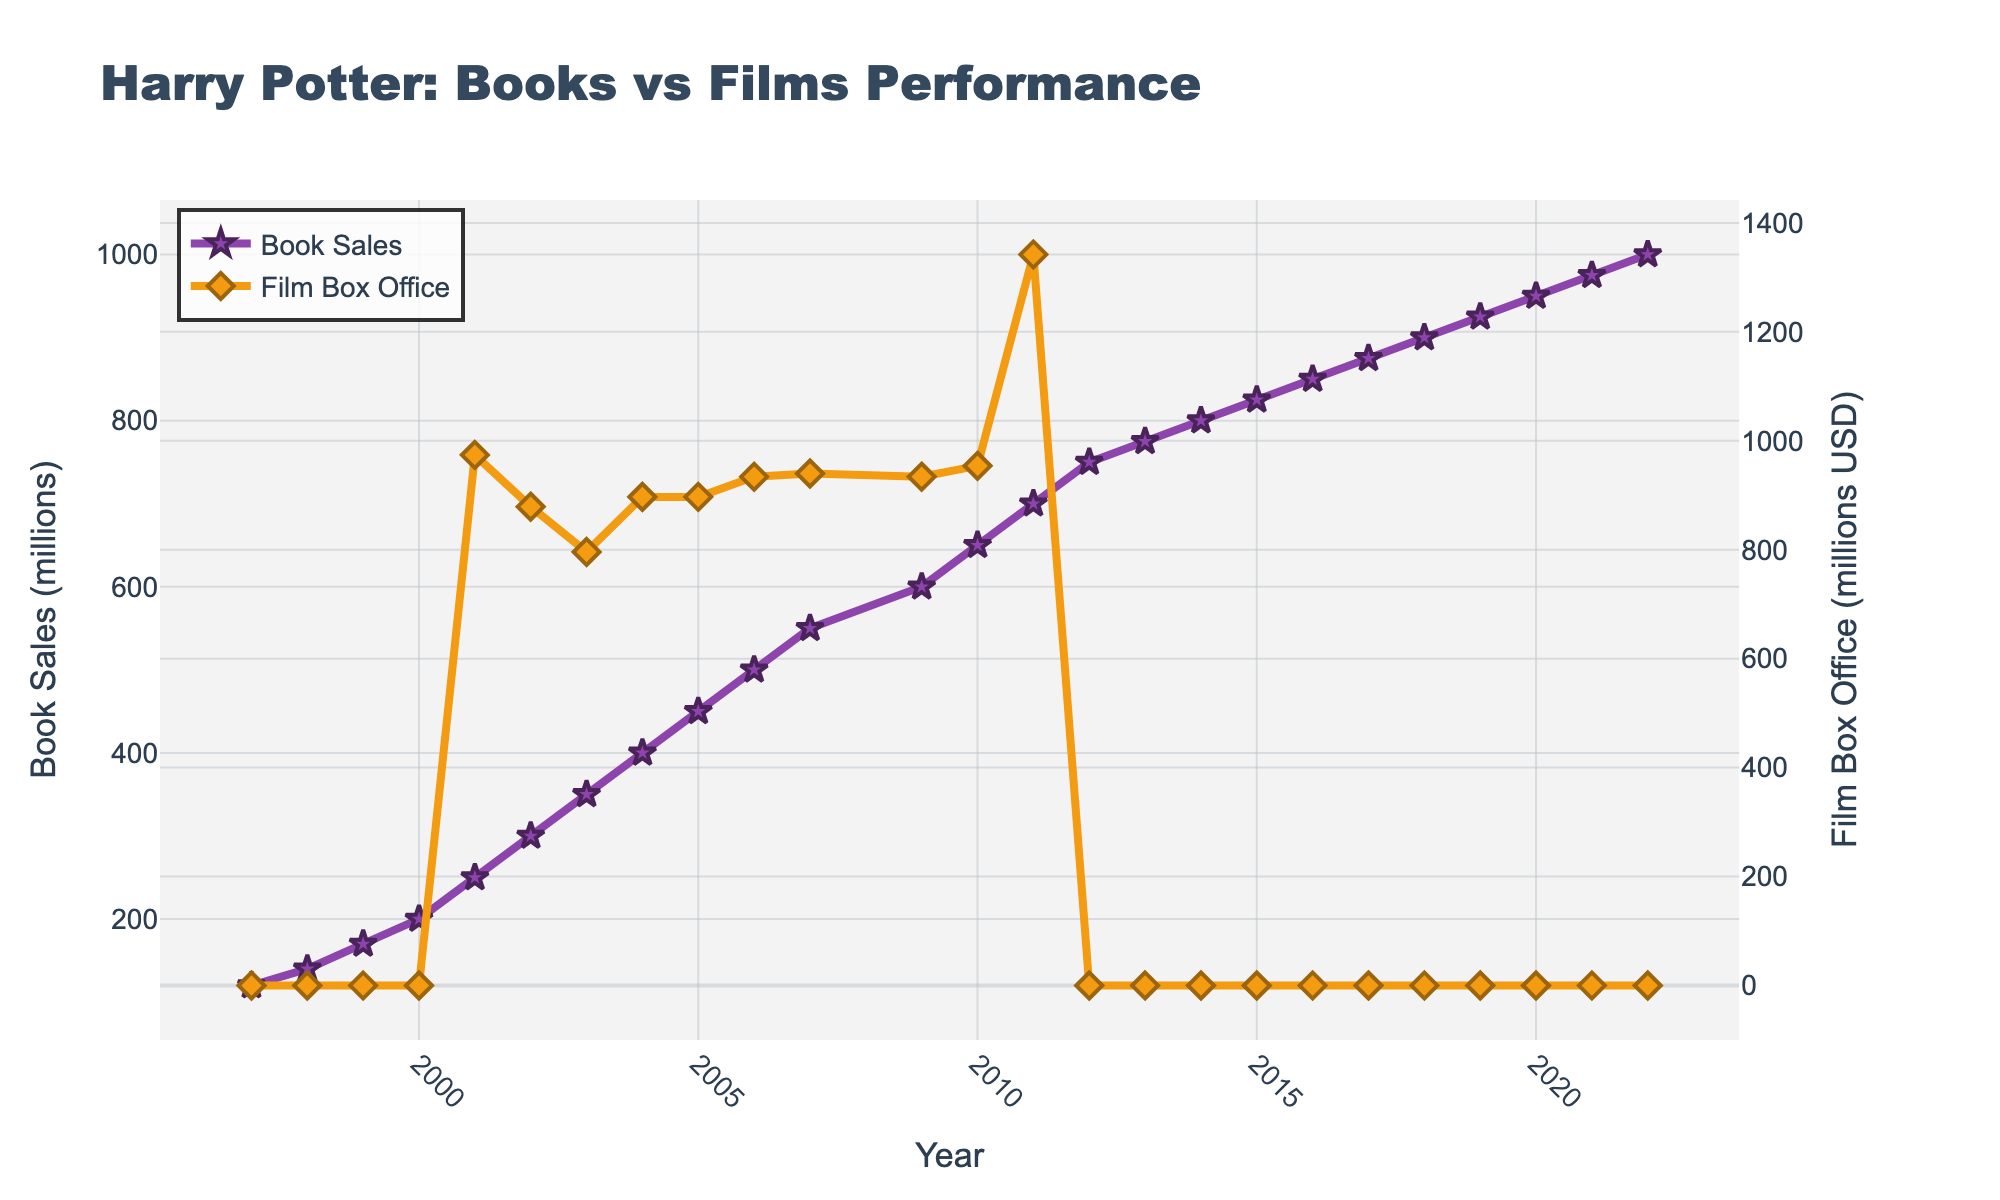What happens to book sales after the release of the first film in 2001? Prior to 2001, we observe a steady yearly increase in book sales. After the film's release in 2001, this increase continues, showing a rapid rise from 250 million in 2001 to 350 million in 2003, suggesting a potential uptick due to the film's influence.
Answer: Book sales increase rapidly Which year marks the peak of the film box office earnings? By examining the peaks in the film box office line, we find that 2011 marks the peak with approximately $1342 million in earnings.
Answer: 2011 Compare the rates of increase in book sales and film box office earnings in 2001-2003. Which grows faster? To compare, we calculate the differences for both metrics from 2001 to 2003. For book sales, (350 - 250) = 100 million; for film box office earnings, (796 - 974) = -178 million. Hence, book sales show a substantial increase while film earnings decline.
Answer: Book sales grow faster Is there a year when book sales surpassed film box office earnings? By examining the figure, the book sales consistently surpass the film box office earnings since their tracks do not intersect, especially noticeable in 2011 where book sales are 700 million and film earnings are $1342 million.
Answer: No What happens to film box office earnings after the release of 'Harry Potter and the Sorcerer's Stone' in 2001? The film earnings start at $974 million in 2001 and exhibit fluctuations with a general declining trend till 2003, slightly recover in 2004 and stabilize around 900 million until peaking in 2011.
Answer: Film earnings initially fluctuate, then stabilize What is the visual difference between the markers used for book sales and film box office? The book sales use star-shaped markers with a purple color and thicker border while the film box office uses diamond-shaped markers with an orange color and thick borders.
Answer: Star for book, diamond for film During which periods are film box office earnings non-zero? From the figure, it is evident that film box office earnings are non-zero from 2001 (the release year of the film) until 2011.
Answer: 2001-2011 How does the trend in book sales compare before and after the last film in 2011? Before 2011, book sales show a steady increase. Post-2011, the book sales continue to increase but at a slower rate, growing from 700 million in 2011 to 1000 million in 2022.
Answer: Steady before, slower increase after What is the difference between book sales in 1997 and 2022? The book sales in 1997 are 120 million and in 2022 they are 1000 million. The difference is 1000 - 120 = 880 million.
Answer: 880 million What could be inferred about the popularity of the Harry Potter franchise from the concurrent trends in both metrics? The increasing book sales and significant box office earnings indicate a sustained and possibly growing popularity of the franchise, spurred by the films, evident from the sharp rises in certain periods.
Answer: Sustained and growing popularity 